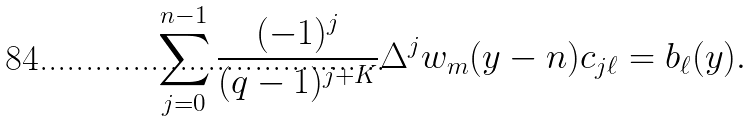<formula> <loc_0><loc_0><loc_500><loc_500>\sum _ { j = 0 } ^ { n - 1 } \frac { ( - 1 ) ^ { j } } { ( q - 1 ) ^ { j + K } } \Delta ^ { j } w _ { m } ( y - n ) c _ { j \ell } = b _ { \ell } ( y ) .</formula> 